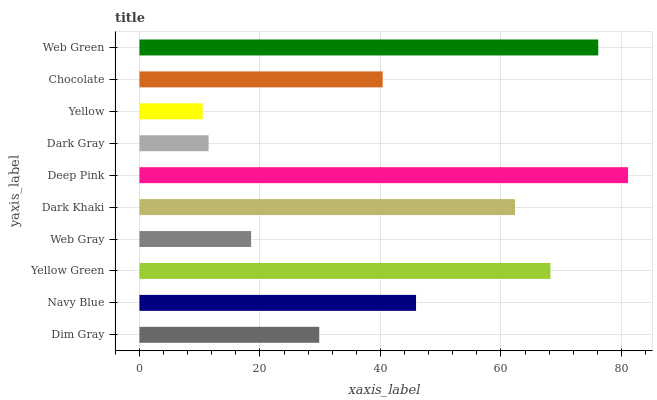Is Yellow the minimum?
Answer yes or no. Yes. Is Deep Pink the maximum?
Answer yes or no. Yes. Is Navy Blue the minimum?
Answer yes or no. No. Is Navy Blue the maximum?
Answer yes or no. No. Is Navy Blue greater than Dim Gray?
Answer yes or no. Yes. Is Dim Gray less than Navy Blue?
Answer yes or no. Yes. Is Dim Gray greater than Navy Blue?
Answer yes or no. No. Is Navy Blue less than Dim Gray?
Answer yes or no. No. Is Navy Blue the high median?
Answer yes or no. Yes. Is Chocolate the low median?
Answer yes or no. Yes. Is Dark Khaki the high median?
Answer yes or no. No. Is Navy Blue the low median?
Answer yes or no. No. 